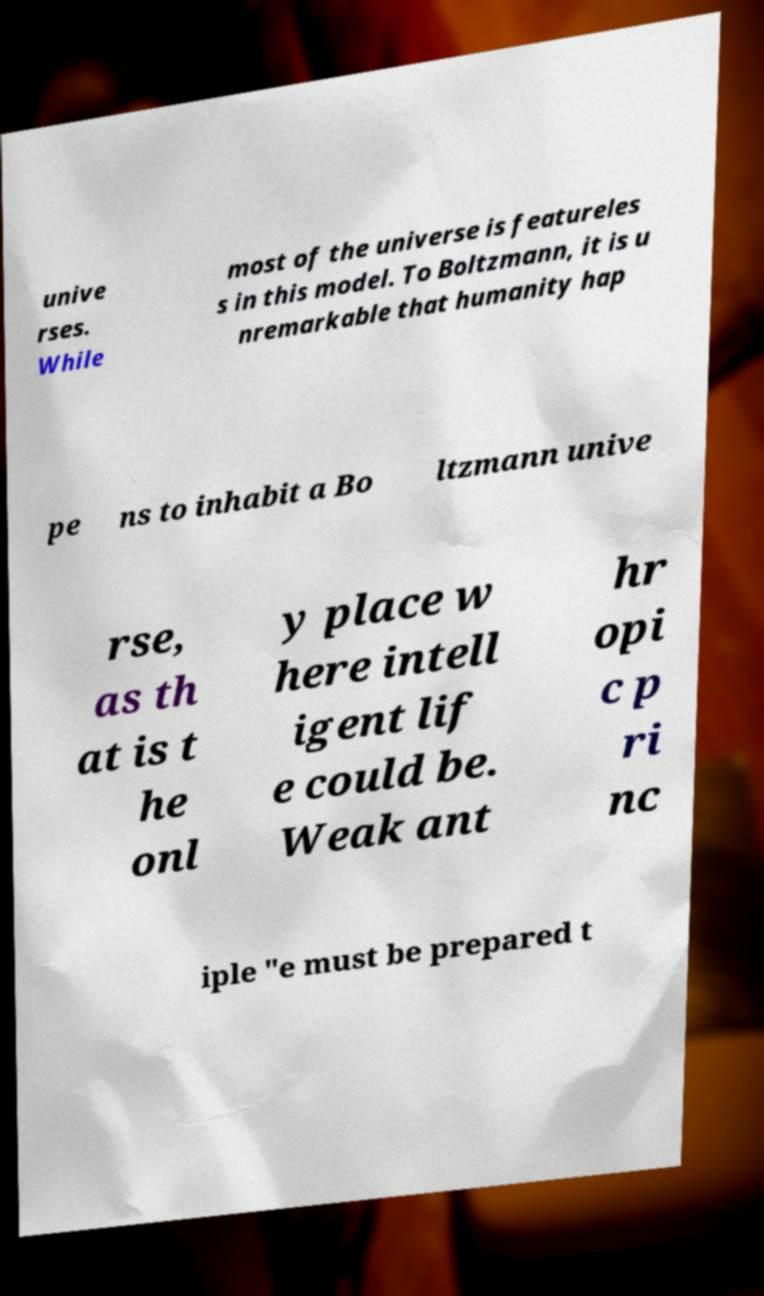For documentation purposes, I need the text within this image transcribed. Could you provide that? unive rses. While most of the universe is featureles s in this model. To Boltzmann, it is u nremarkable that humanity hap pe ns to inhabit a Bo ltzmann unive rse, as th at is t he onl y place w here intell igent lif e could be. Weak ant hr opi c p ri nc iple "e must be prepared t 